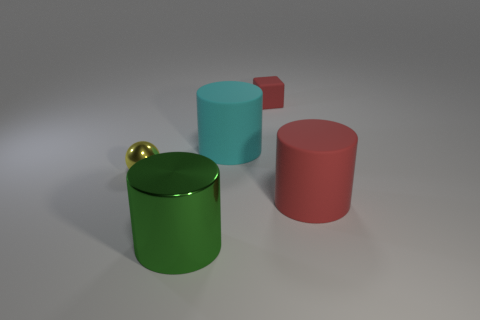Are the small object to the right of the shiny sphere and the tiny thing that is in front of the small red cube made of the same material? Based on the appearance, the small golden sphere and the tiny object in front of the red cube seem to have different finishes suggesting they might not be made from the same material. The sphere has a reflective, metallic finish, while the other object is not clearly visible but appears less reflective, implying a potential difference in material. 